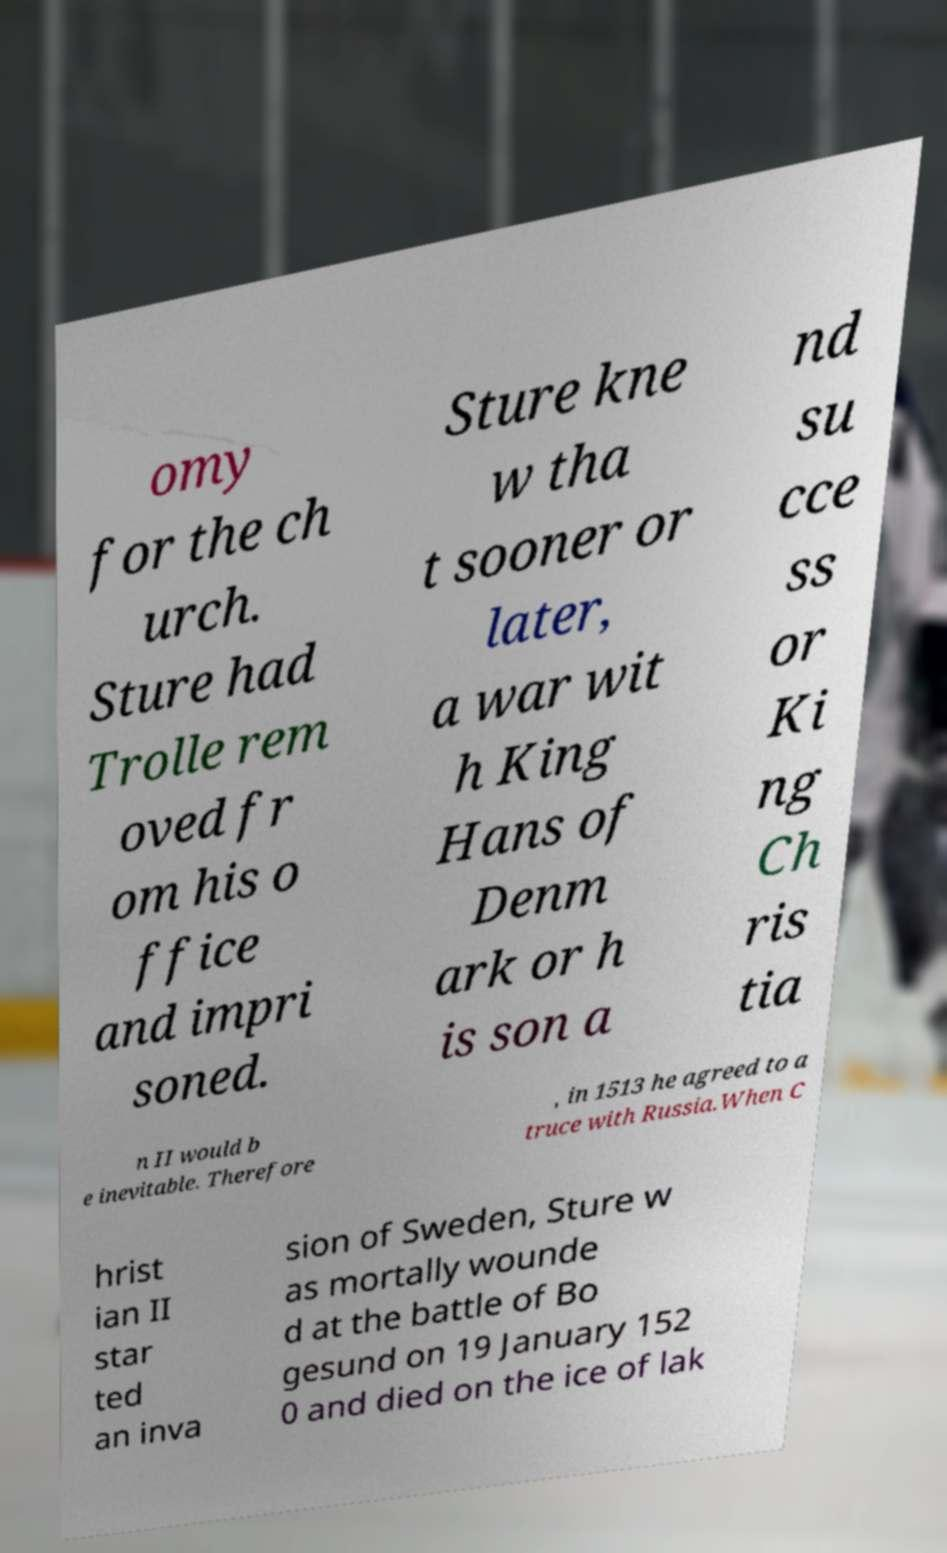Can you accurately transcribe the text from the provided image for me? omy for the ch urch. Sture had Trolle rem oved fr om his o ffice and impri soned. Sture kne w tha t sooner or later, a war wit h King Hans of Denm ark or h is son a nd su cce ss or Ki ng Ch ris tia n II would b e inevitable. Therefore , in 1513 he agreed to a truce with Russia.When C hrist ian II star ted an inva sion of Sweden, Sture w as mortally wounde d at the battle of Bo gesund on 19 January 152 0 and died on the ice of lak 